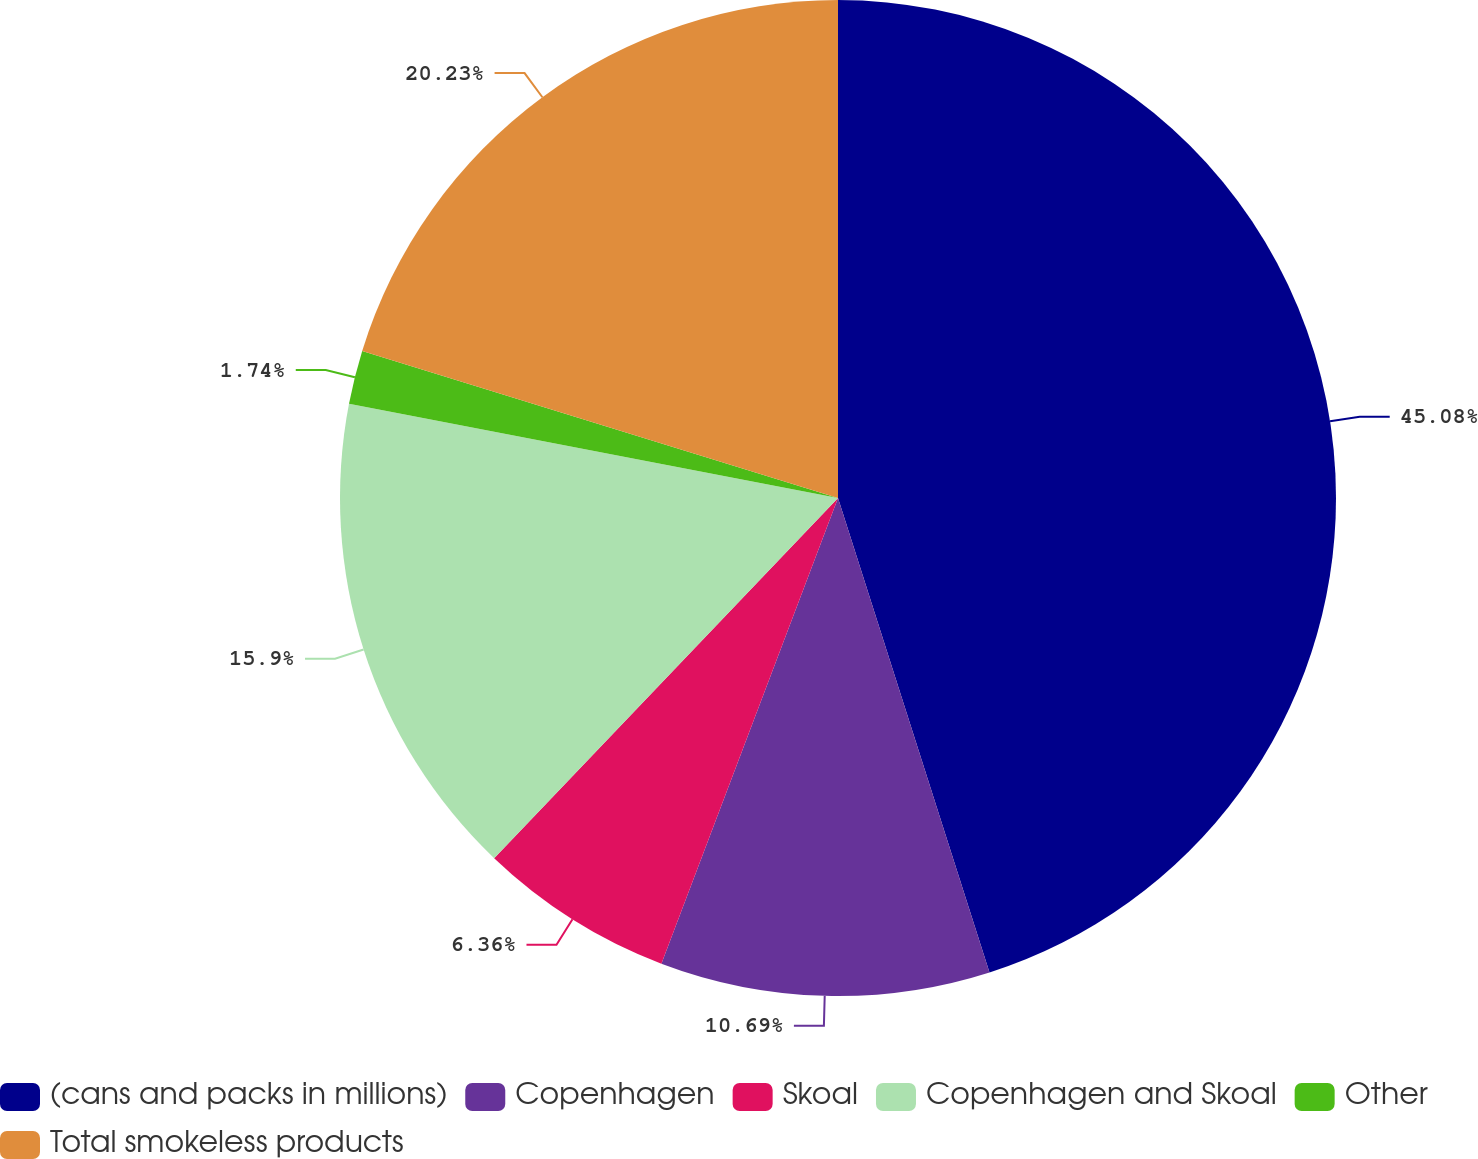Convert chart to OTSL. <chart><loc_0><loc_0><loc_500><loc_500><pie_chart><fcel>(cans and packs in millions)<fcel>Copenhagen<fcel>Skoal<fcel>Copenhagen and Skoal<fcel>Other<fcel>Total smokeless products<nl><fcel>45.08%<fcel>10.69%<fcel>6.36%<fcel>15.9%<fcel>1.74%<fcel>20.23%<nl></chart> 